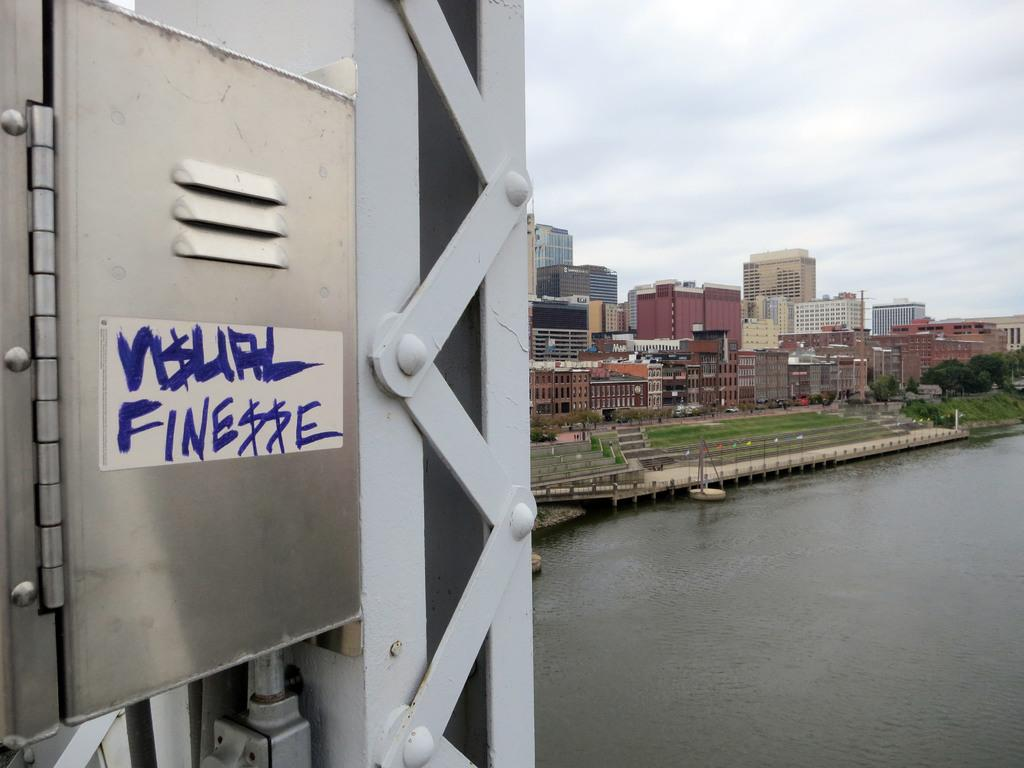What is the main structure in the image? There is a tower in the image. How is the tower secured? The tower is fixed with bolts. What material is the tower made of? The tower appears to be made of steel. What is written or depicted on the tower? There are letters on the tower. What can be seen in the background of the image? There is water, buildings, trees, and the sky visible in the image. Can you tell me how many arguments are taking place in the image? There are no arguments depicted in the image; it features a tower and various background elements. What type of feet can be seen on the tower in the image? There are no feet visible on the tower in the image; it is a steel structure with bolts. 